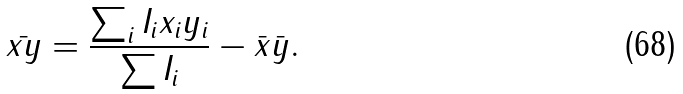Convert formula to latex. <formula><loc_0><loc_0><loc_500><loc_500>\bar { x y } = \frac { \sum _ { i } I _ { i } x _ { i } y _ { i } } { \sum I _ { i } } - \bar { x } \bar { y } .</formula> 